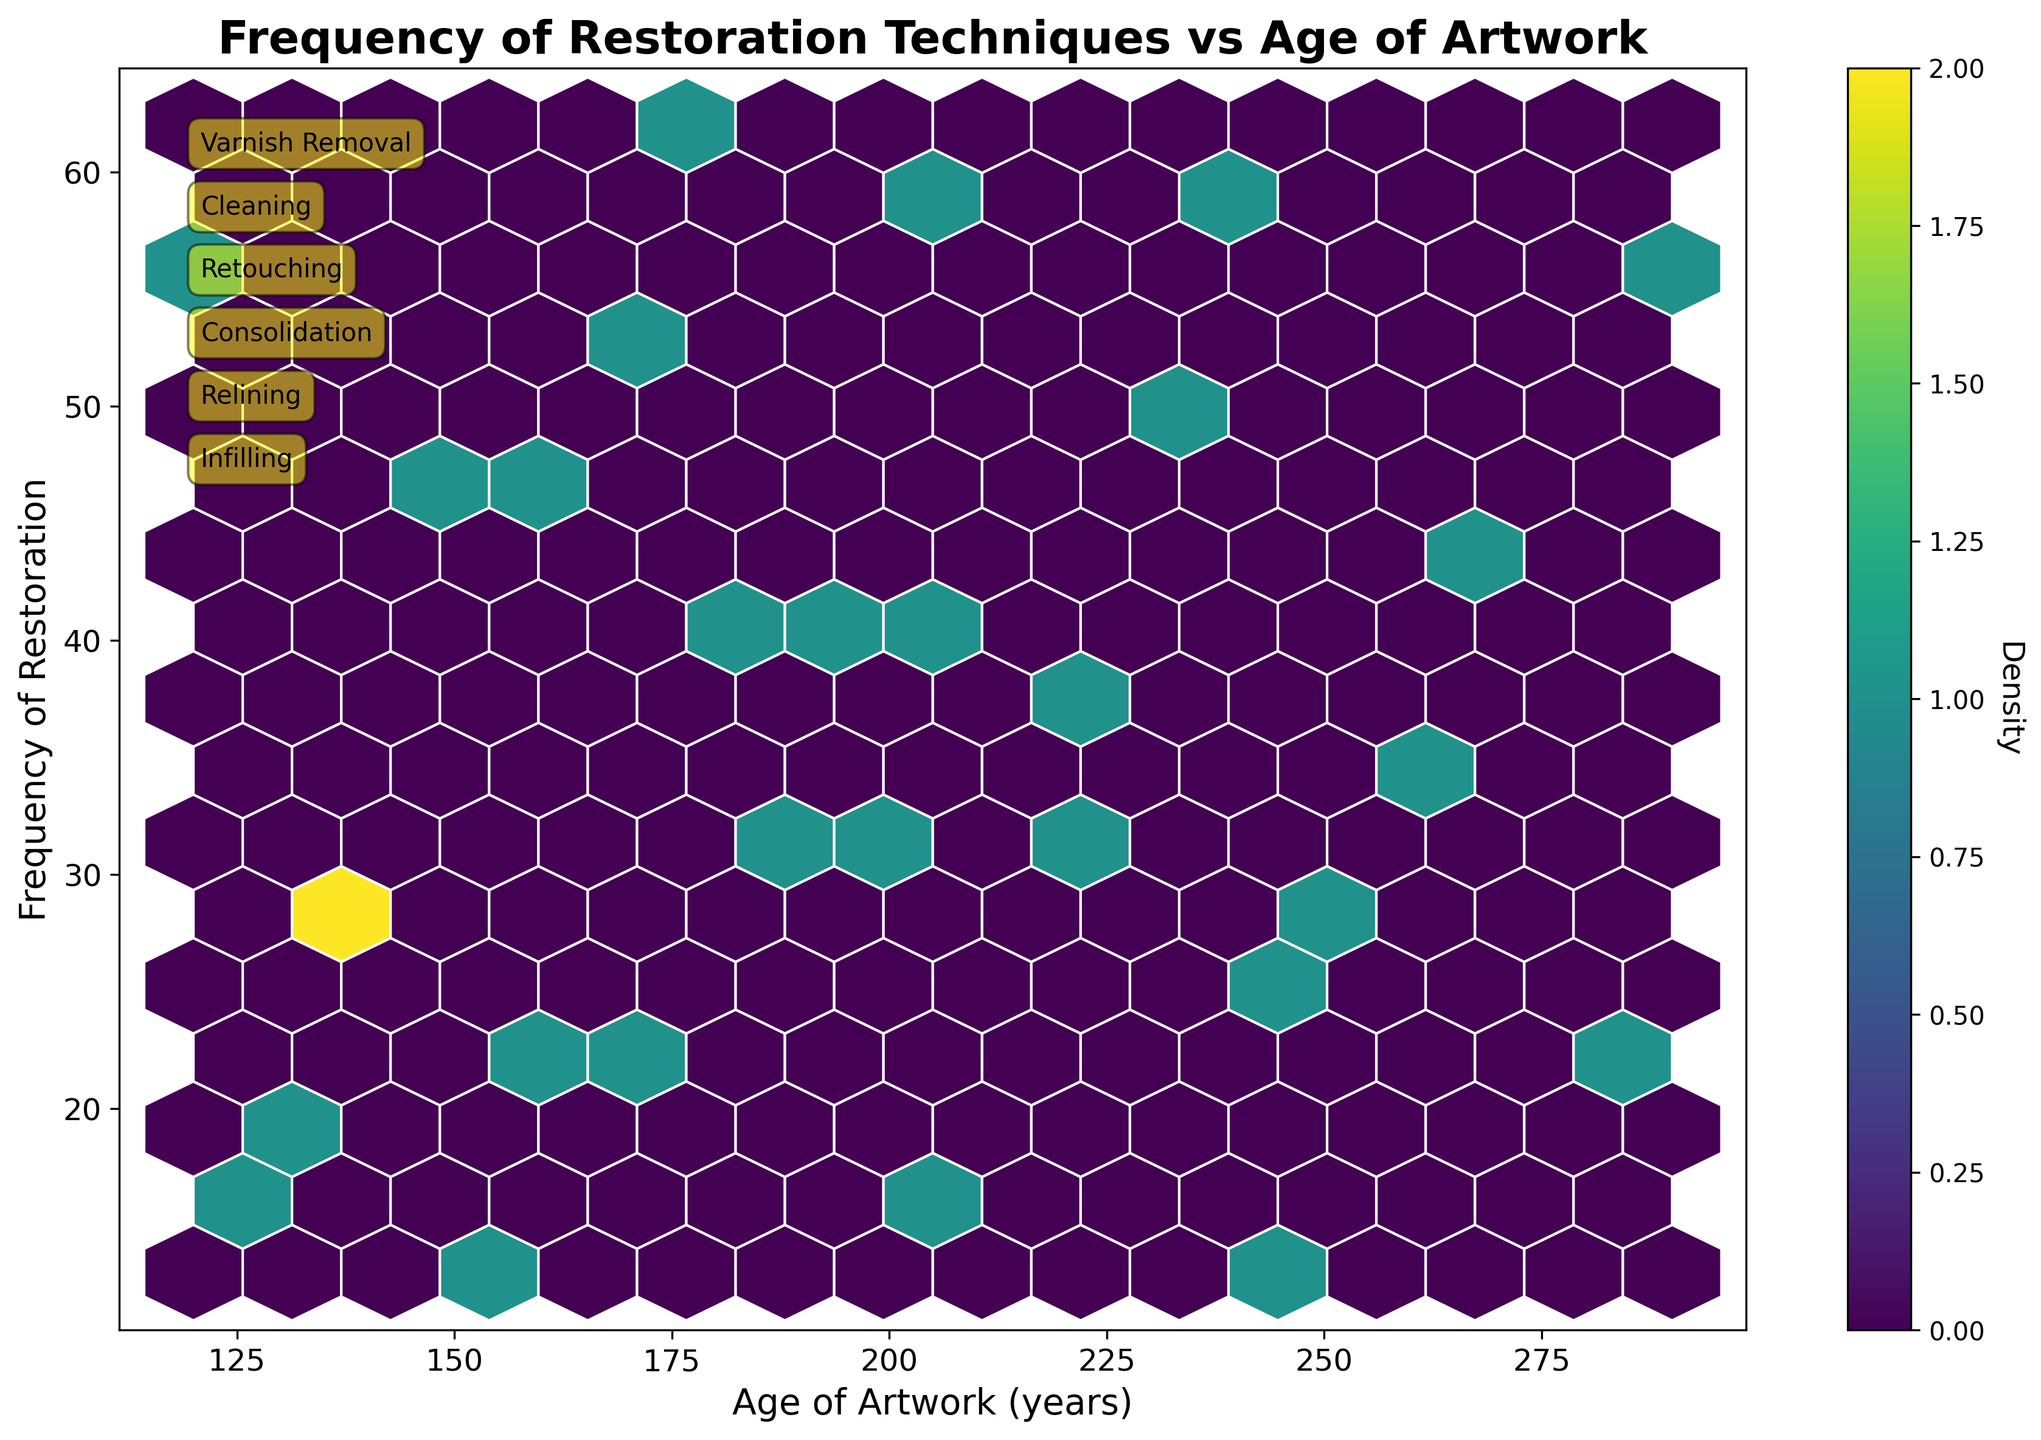What's the title of the plot? The title is usually found at the top of the figure and provides a summary of what the plot represents. The title here is clearly stated at the top.
Answer: Frequency of Restoration Techniques vs Age of Artwork What axes labels are used in the plot? The axes labels are typically located along the x-axis and y-axis, describing what each axis represents. The x-axis is labeled 'Age of Artwork (years)' and the y-axis is labeled 'Frequency of Restoration'.
Answer: Age of Artwork (years), Frequency of Restoration What color scheme is used in the hexbin plot? The color scheme defines how data density is visualized in the hexbin plot. The plot uses a 'viridis' color map, which ranges from yellow to dark purple.
Answer: Viridis What restoration technique has the highest frequency in the data? To find the restoration technique with the highest frequency, look at the y-axis values where each technique is annotated and see which has the highest value. 'Cleaning' has the highest annotations close to 60.
Answer: Cleaning How does frequency change with the age of the artwork? To determine the trend, observe how data points (represented as colored hexagons) are distributed across different ages. Generally, higher frequencies (more densely colored hexagons) are clustered in the middle to older age ranges around 180-240 years.
Answer: Higher frequencies are clustered around 180-240 years What age range of artwork has the least frequency of any restoration technique? Look for the area on the plot with the least number of colored hexagons, which indicates low frequency. The range around 100-130 years has the least frequency.
Answer: 100-130 years Which age group has the highest density of frequencies? Density is higher where the color intensifies. By examining the plot, the age group around 160-200 years exhibits the highest density.
Answer: 160-200 years How is the density shown in the plot? Density is indicated by the color intensity within the hexagons, with darker colors representing higher densities. The color bar on the side also explains this density mapping.
Answer: Darker colors indicate higher density What information does the color bar provide? The color bar helps in interpreting the density of the data points. It shows how the color intensity correlates with density, with denser areas in darker shades of the viridis color map.
Answer: Correlation of color intensity with density Is there a noticeable correlation between the age of the artwork and the occurrence of 'Varnish Removal'? We can look for the annotated 'Varnish Removal' data points and their distribution across different ages and frequencies to see if there's a pattern. 'Varnish Removal' appears at various ages with frequencies generally around mid to high.
Answer: There is a positive correlation with varying ages 